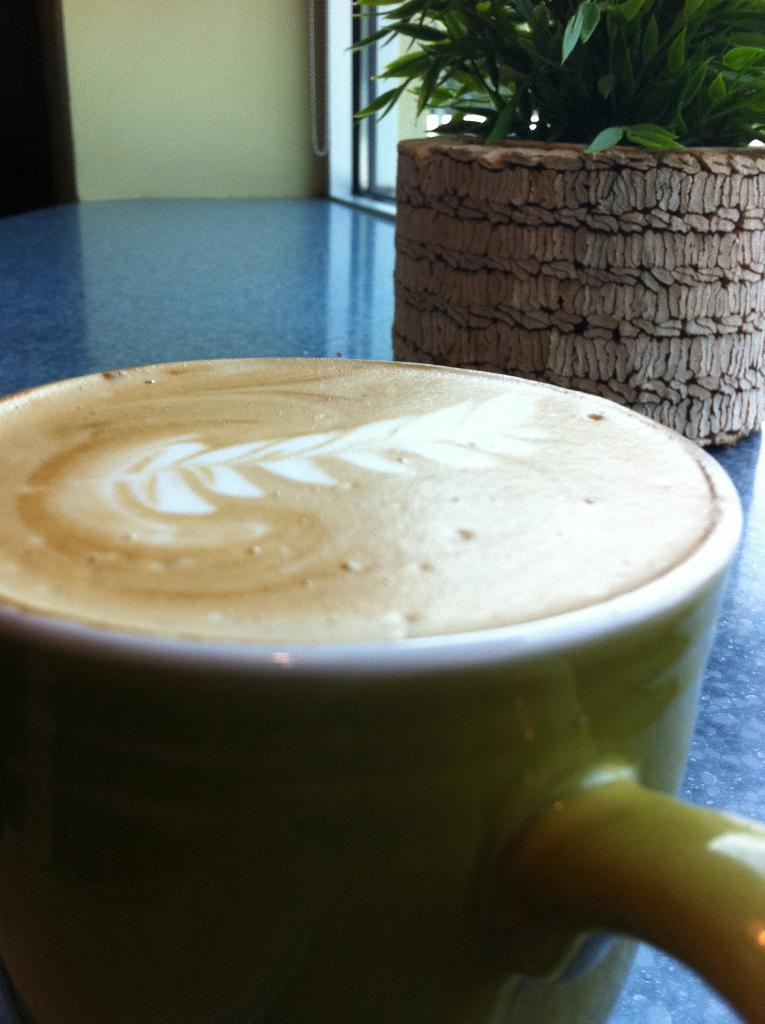What is one object that can be seen on the table in the image? There is a coffee mug on the table in the image. What other item is present on the table in the image? There is a houseplant on the table in the image. Can you describe the location of both the coffee mug and the houseplant in the image? Both the coffee mug and the houseplant are placed on a table in the image. What type of patch is sewn onto the coffee mug in the image? There is no patch sewn onto the coffee mug in the image. 